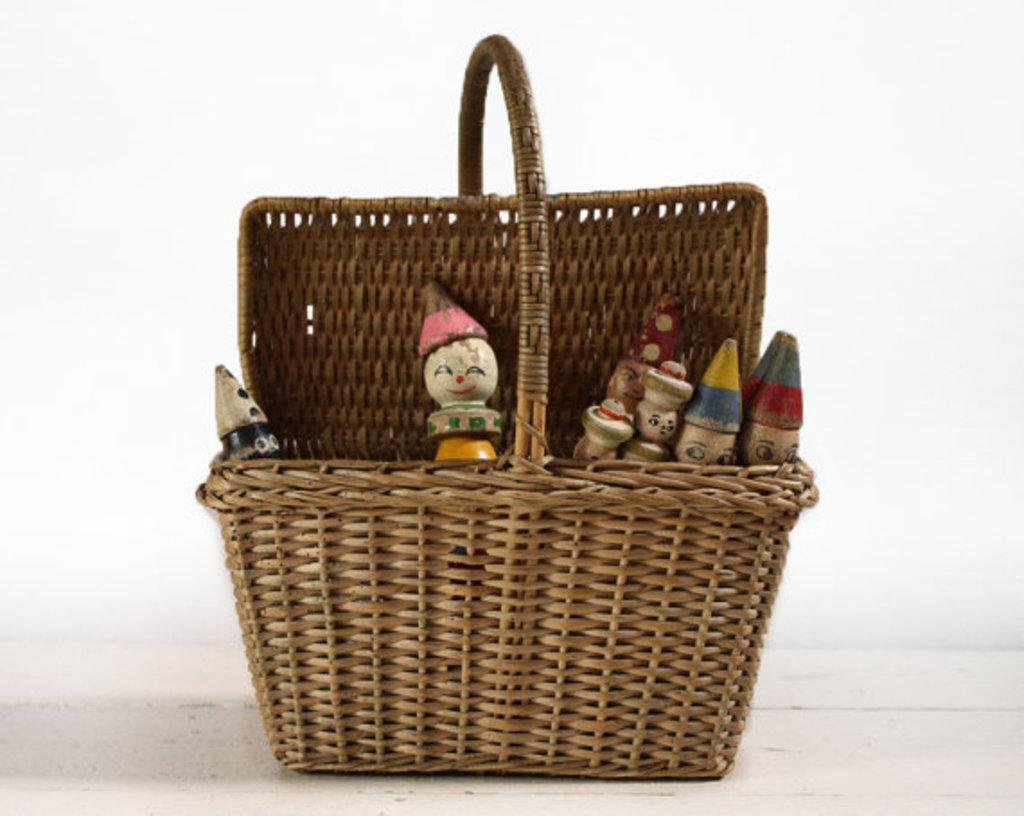What object is located in the front of the image? There is a basket in the front of the image. What is inside the basket? There are puppets inside the basket. Can you see any fairies flying around the basket in the image? There are no fairies visible in the image. What type of cloud is present in the image? There is no cloud present in the image. What part of the body is visible in the image? The provided facts do not mention any specific body parts being visible in the image. 